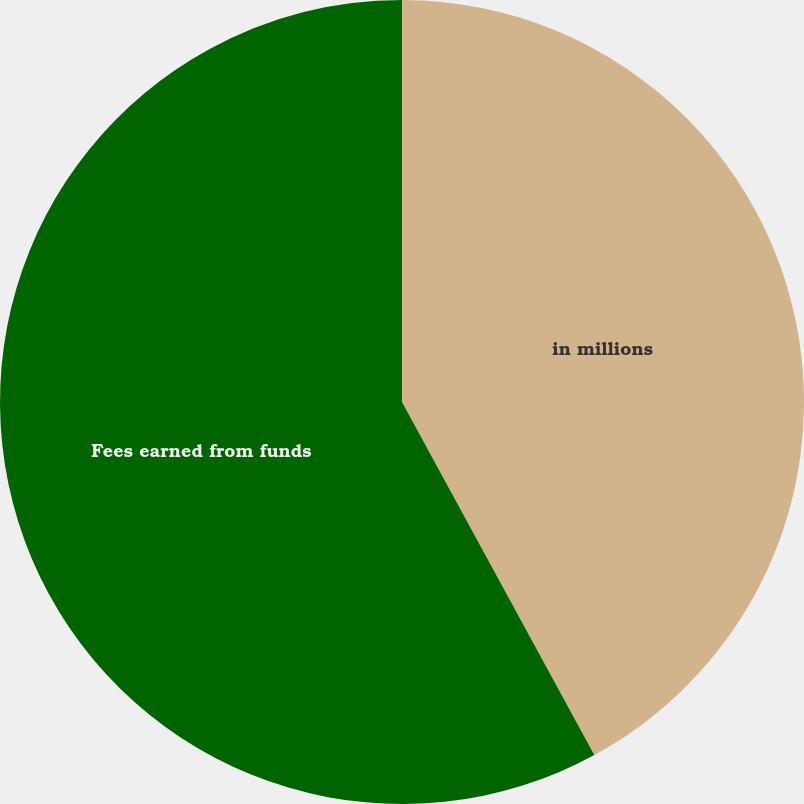<chart> <loc_0><loc_0><loc_500><loc_500><pie_chart><fcel>in millions<fcel>Fees earned from funds<nl><fcel>42.06%<fcel>57.94%<nl></chart> 